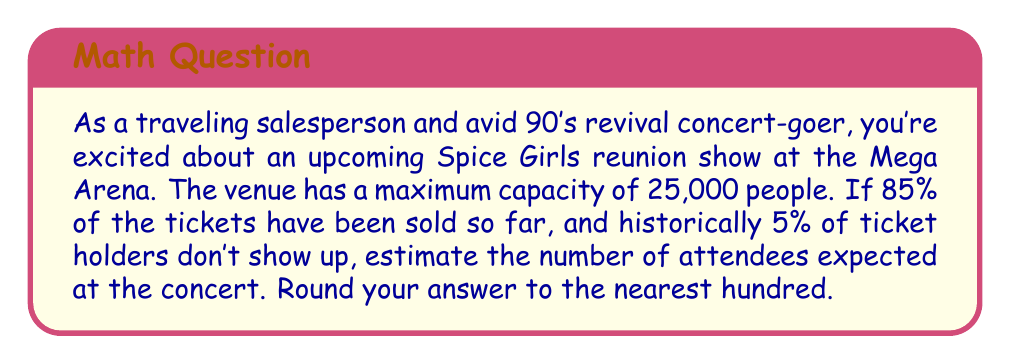Can you answer this question? Let's approach this problem step-by-step:

1. Calculate the number of tickets sold:
   $$ \text{Tickets sold} = 85\% \times 25,000 = 0.85 \times 25,000 = 21,250 \text{ tickets} $$

2. Calculate the expected number of ticket holders who will show up:
   $$ \text{Expected attendance rate} = 100\% - 5\% = 95\% = 0.95 $$
   $$ \text{Expected attendees} = 21,250 \times 0.95 = 20,187.5 \text{ people} $$

3. Round the result to the nearest hundred:
   20,187.5 rounds to 20,200
Answer: The estimated number of attendees at the Spice Girls reunion concert is 20,200 people. 